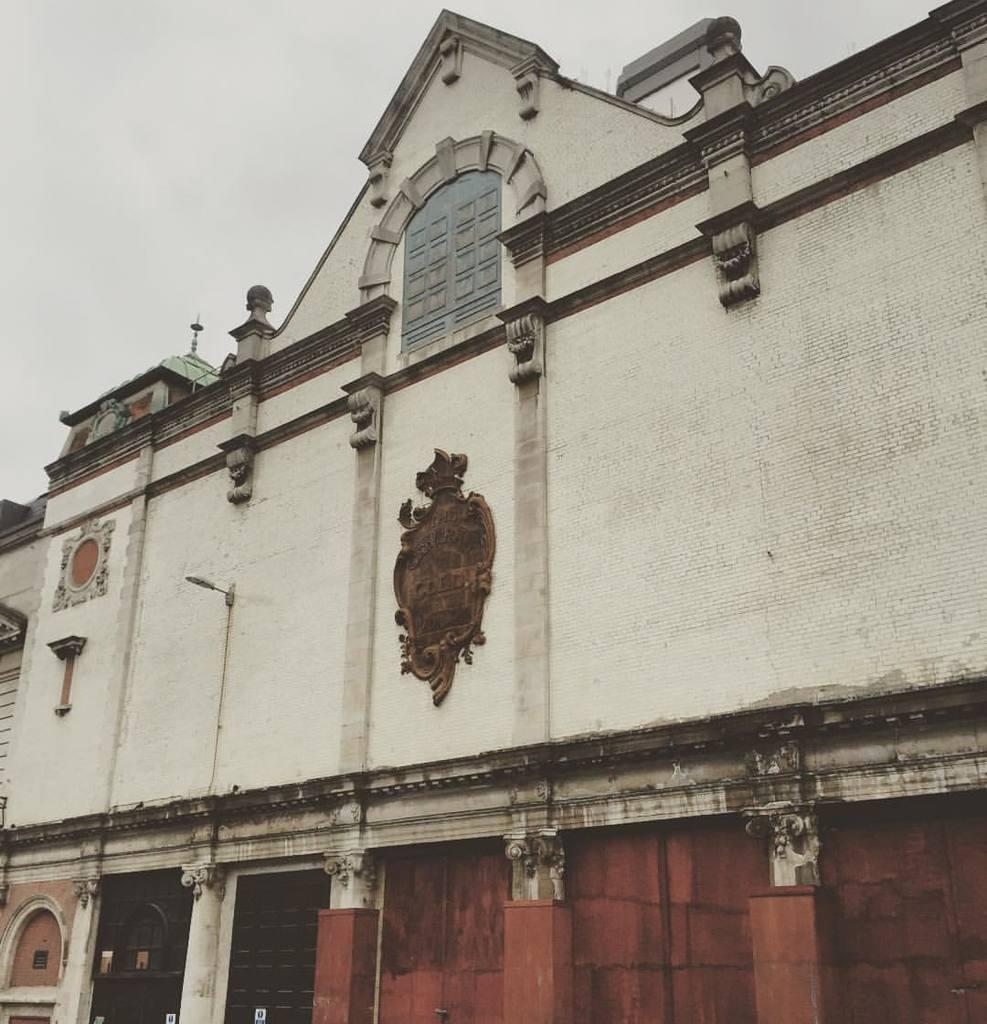What type of structure is present in the image? There is a building in the image. What else can be seen in the image besides the building? There are objects in the image. What can be seen in the background of the image? The sky is visible in the background of the image. What type of unit is being measured by the brick in the image? There is no brick present in the image, so it is not possible to determine what type of unit is being measured. 